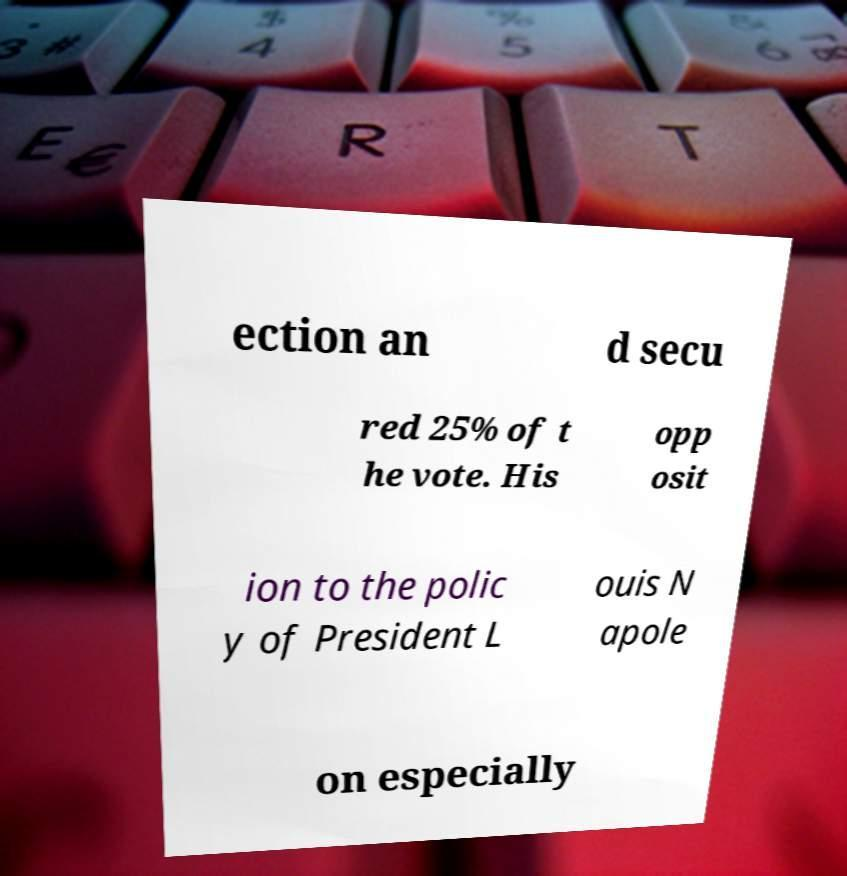What messages or text are displayed in this image? I need them in a readable, typed format. ection an d secu red 25% of t he vote. His opp osit ion to the polic y of President L ouis N apole on especially 